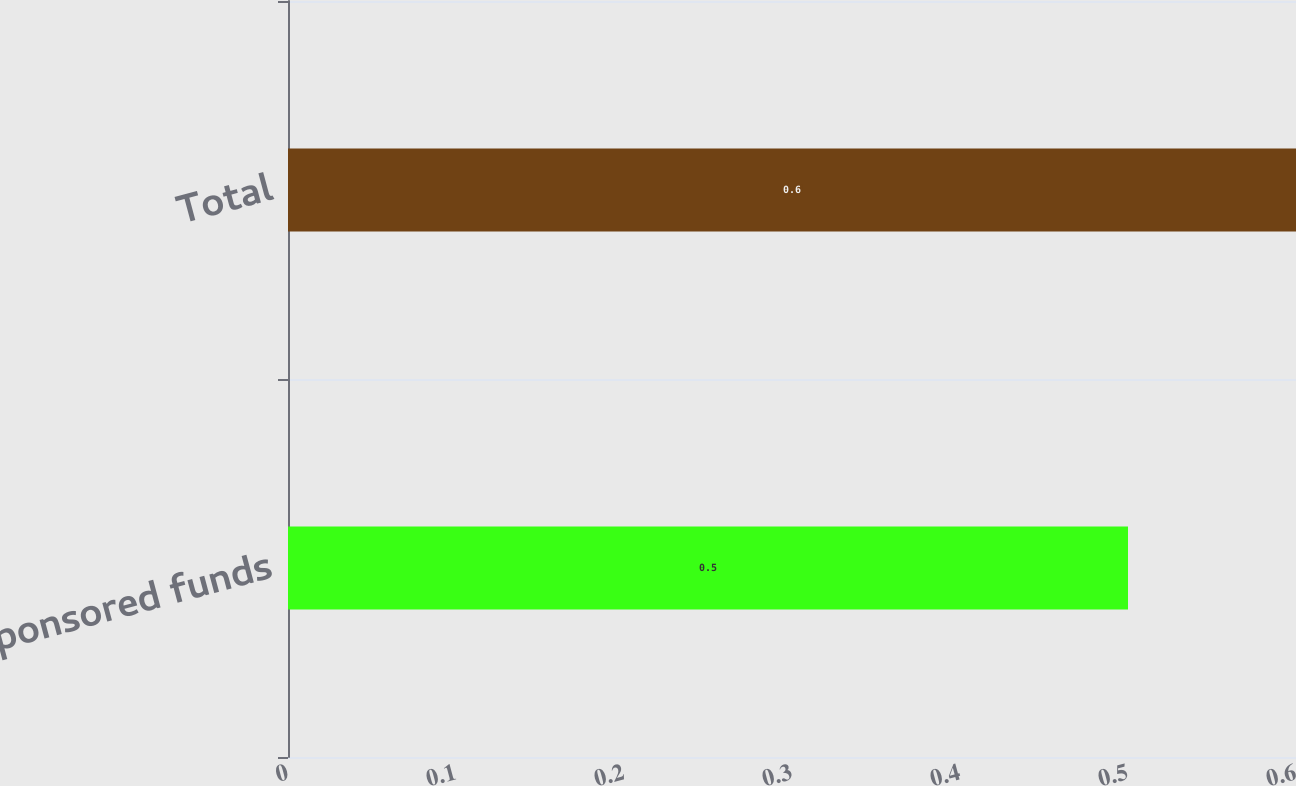Convert chart to OTSL. <chart><loc_0><loc_0><loc_500><loc_500><bar_chart><fcel>Sponsored funds<fcel>Total<nl><fcel>0.5<fcel>0.6<nl></chart> 